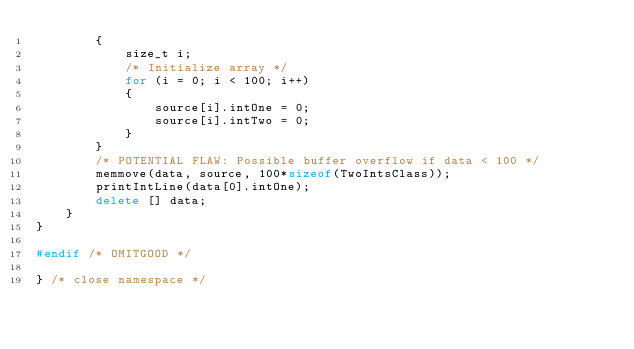Convert code to text. <code><loc_0><loc_0><loc_500><loc_500><_C++_>        {
            size_t i;
            /* Initialize array */
            for (i = 0; i < 100; i++)
            {
                source[i].intOne = 0;
                source[i].intTwo = 0;
            }
        }
        /* POTENTIAL FLAW: Possible buffer overflow if data < 100 */
        memmove(data, source, 100*sizeof(TwoIntsClass));
        printIntLine(data[0].intOne);
        delete [] data;
    }
}

#endif /* OMITGOOD */

} /* close namespace */
</code> 